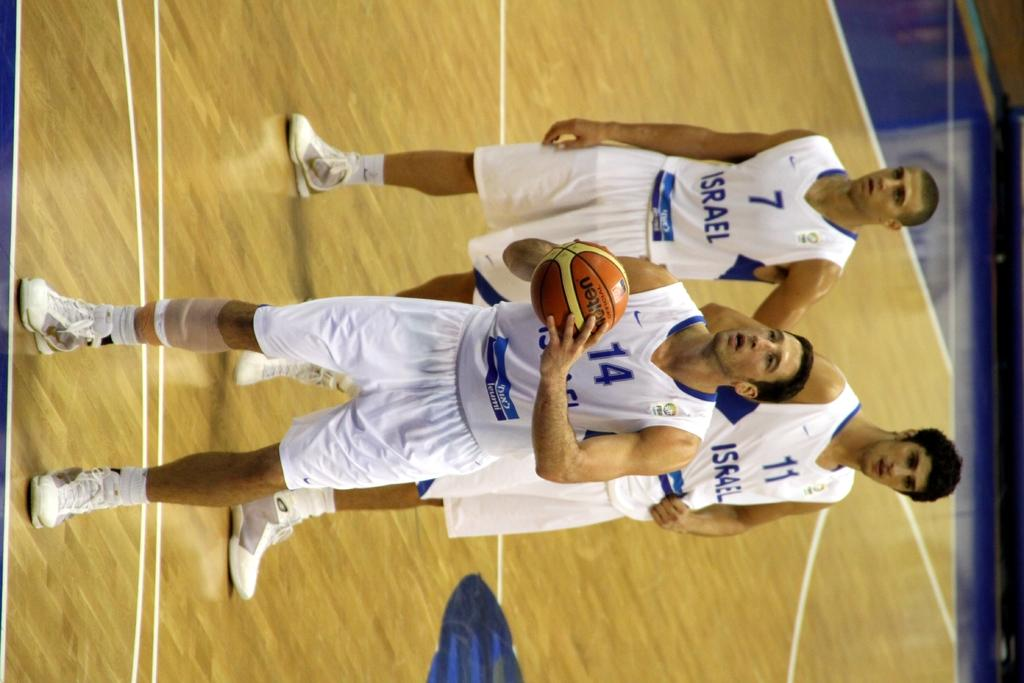Provide a one-sentence caption for the provided image. Basketball player wearing number 14 shooting the basketball. 